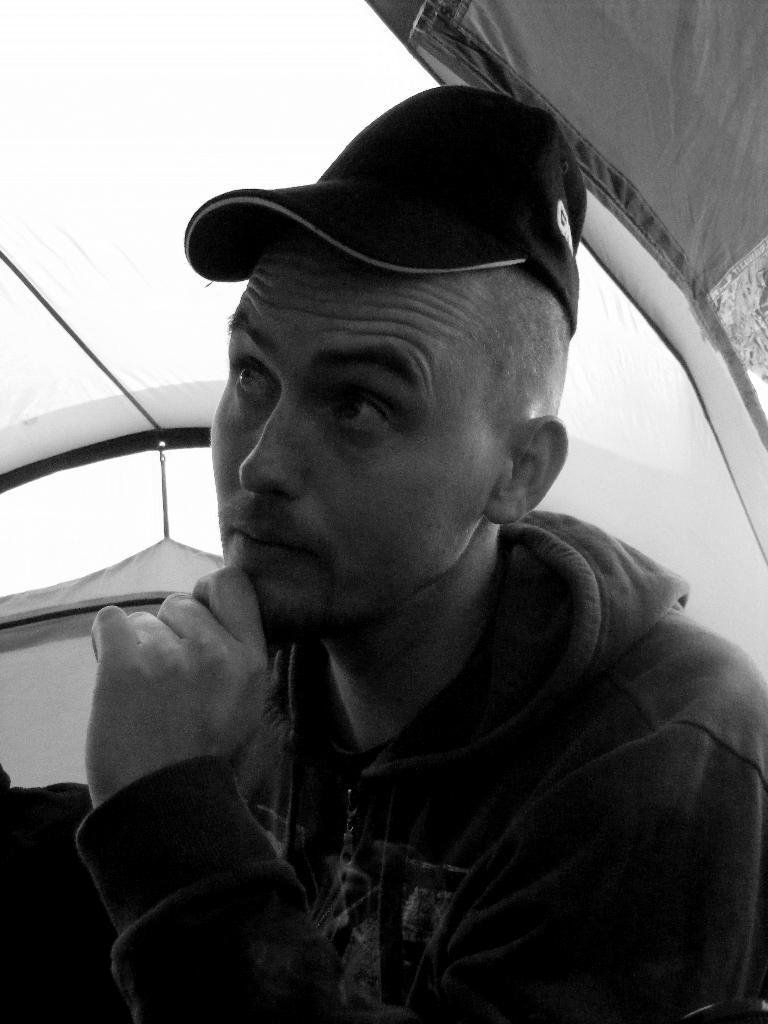How would you summarize this image in a sentence or two? This is a black and white picture, there is a man with jacket and cap looking at the left side under a tent. 